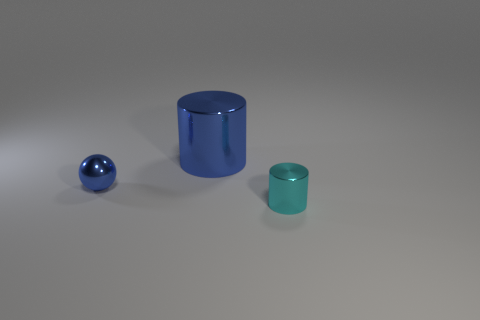Add 3 blue metallic spheres. How many objects exist? 6 Subtract all cylinders. How many objects are left? 1 Subtract all blue shiny cylinders. Subtract all blue cylinders. How many objects are left? 1 Add 3 cyan metallic cylinders. How many cyan metallic cylinders are left? 4 Add 2 tiny gray balls. How many tiny gray balls exist? 2 Subtract 0 yellow cubes. How many objects are left? 3 